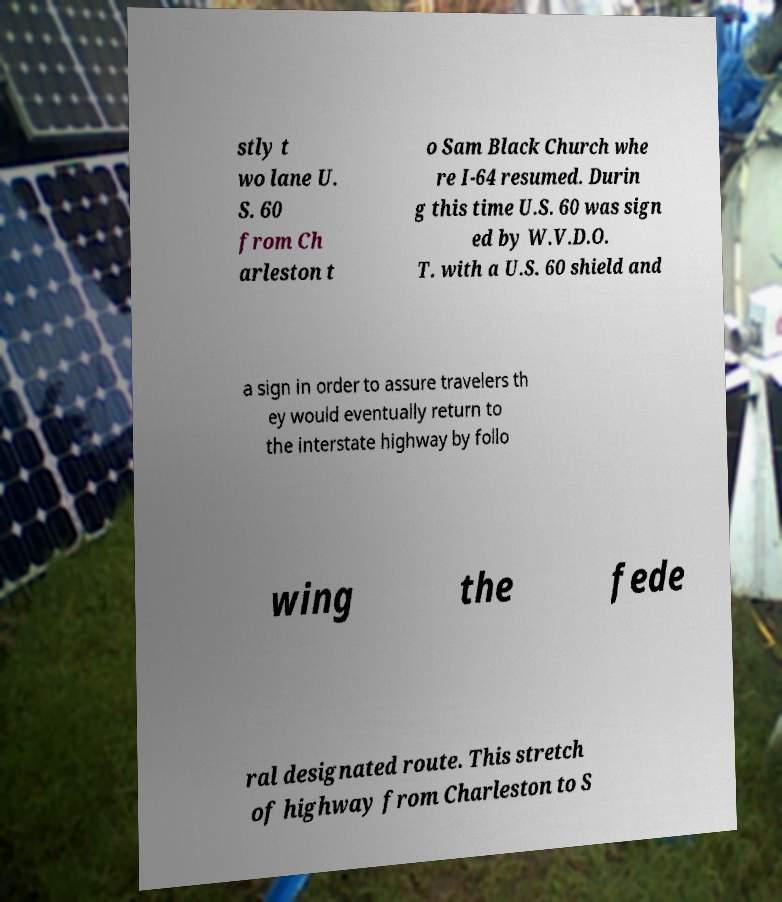Could you extract and type out the text from this image? stly t wo lane U. S. 60 from Ch arleston t o Sam Black Church whe re I-64 resumed. Durin g this time U.S. 60 was sign ed by W.V.D.O. T. with a U.S. 60 shield and a sign in order to assure travelers th ey would eventually return to the interstate highway by follo wing the fede ral designated route. This stretch of highway from Charleston to S 